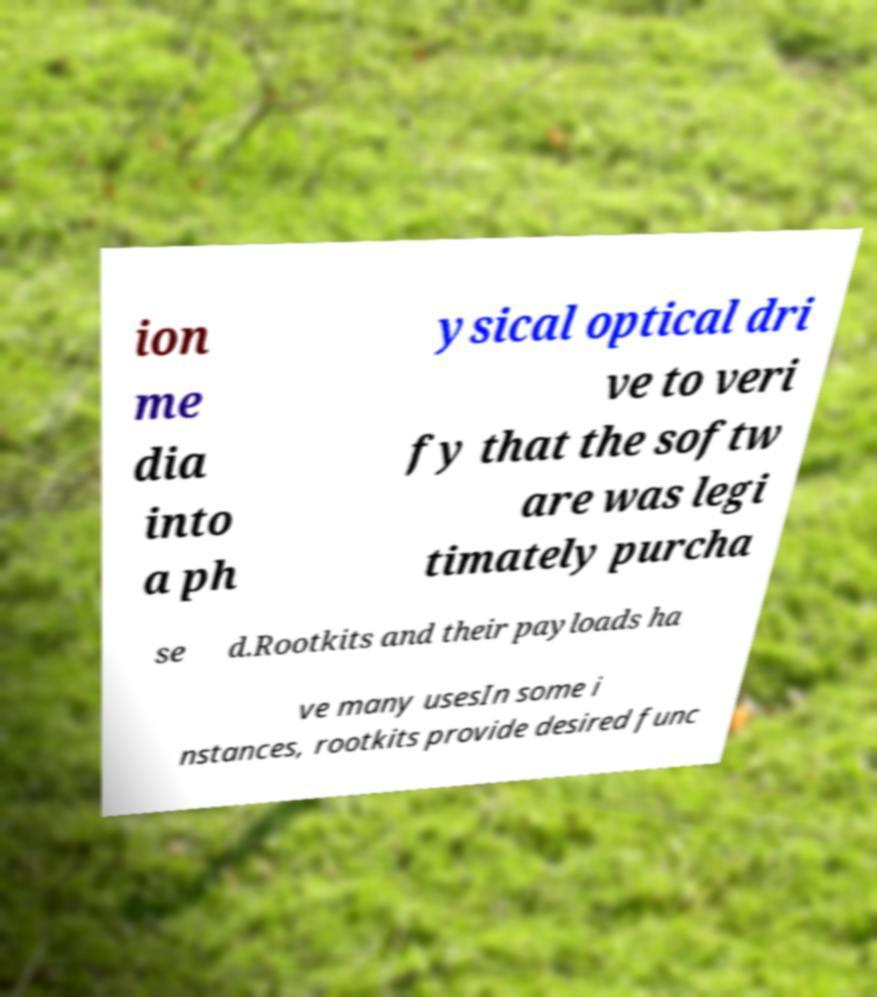Can you accurately transcribe the text from the provided image for me? ion me dia into a ph ysical optical dri ve to veri fy that the softw are was legi timately purcha se d.Rootkits and their payloads ha ve many usesIn some i nstances, rootkits provide desired func 